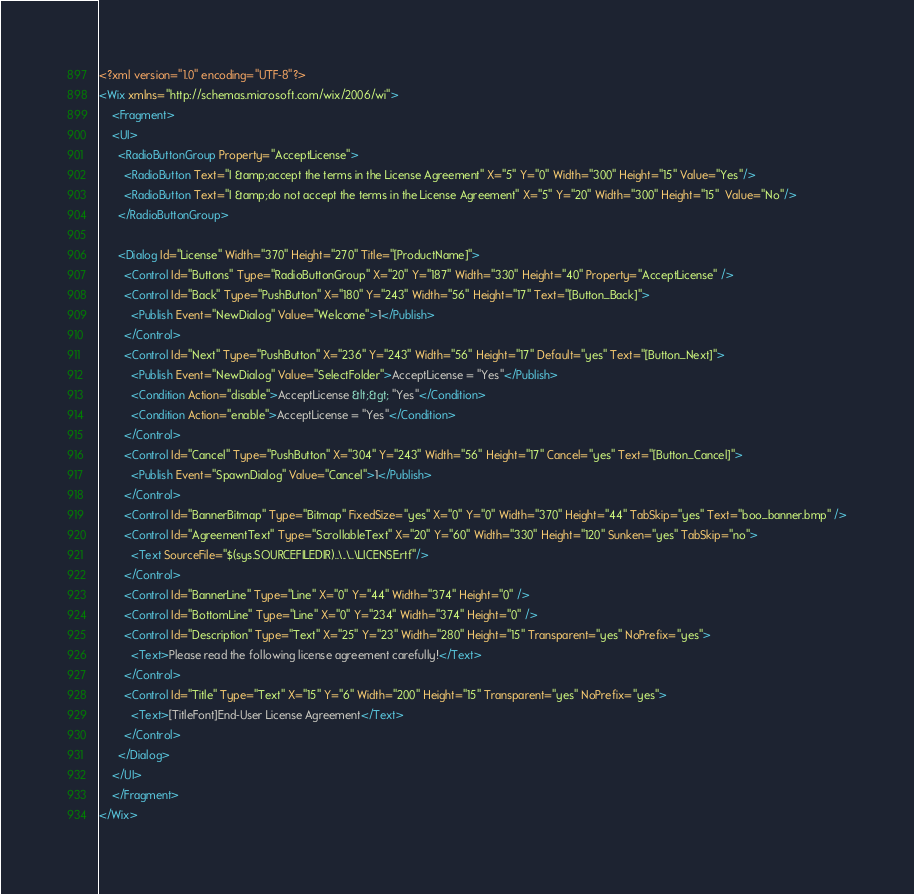Convert code to text. <code><loc_0><loc_0><loc_500><loc_500><_XML_><?xml version="1.0" encoding="UTF-8"?>
<Wix xmlns="http://schemas.microsoft.com/wix/2006/wi">
	<Fragment>
    <UI>
      <RadioButtonGroup Property="AcceptLicense">
        <RadioButton Text="I &amp;accept the terms in the License Agreement" X="5" Y="0" Width="300" Height="15" Value="Yes"/>
        <RadioButton Text="I &amp;do not accept the terms in the License Agreement" X="5" Y="20" Width="300" Height="15"  Value="No"/>
      </RadioButtonGroup>

      <Dialog Id="License" Width="370" Height="270" Title="[ProductName]">
        <Control Id="Buttons" Type="RadioButtonGroup" X="20" Y="187" Width="330" Height="40" Property="AcceptLicense" />
        <Control Id="Back" Type="PushButton" X="180" Y="243" Width="56" Height="17" Text="[Button_Back]">
          <Publish Event="NewDialog" Value="Welcome">1</Publish>
        </Control>
        <Control Id="Next" Type="PushButton" X="236" Y="243" Width="56" Height="17" Default="yes" Text="[Button_Next]">
          <Publish Event="NewDialog" Value="SelectFolder">AcceptLicense = "Yes"</Publish>
          <Condition Action="disable">AcceptLicense &lt;&gt; "Yes"</Condition>
          <Condition Action="enable">AcceptLicense = "Yes"</Condition>
        </Control>
        <Control Id="Cancel" Type="PushButton" X="304" Y="243" Width="56" Height="17" Cancel="yes" Text="[Button_Cancel]">
          <Publish Event="SpawnDialog" Value="Cancel">1</Publish>
        </Control>
        <Control Id="BannerBitmap" Type="Bitmap" FixedSize="yes" X="0" Y="0" Width="370" Height="44" TabSkip="yes" Text="boo_banner.bmp" />
        <Control Id="AgreementText" Type="ScrollableText" X="20" Y="60" Width="330" Height="120" Sunken="yes" TabSkip="no">
          <Text SourceFile="$(sys.SOURCEFILEDIR)..\..\..\LICENSE.rtf"/>
        </Control>
        <Control Id="BannerLine" Type="Line" X="0" Y="44" Width="374" Height="0" />
        <Control Id="BottomLine" Type="Line" X="0" Y="234" Width="374" Height="0" />
        <Control Id="Description" Type="Text" X="25" Y="23" Width="280" Height="15" Transparent="yes" NoPrefix="yes">
          <Text>Please read the following license agreement carefully!</Text>
        </Control>
        <Control Id="Title" Type="Text" X="15" Y="6" Width="200" Height="15" Transparent="yes" NoPrefix="yes">
          <Text>[TitleFont]End-User License Agreement</Text>
        </Control>
      </Dialog>
    </UI>
	</Fragment>
</Wix></code> 